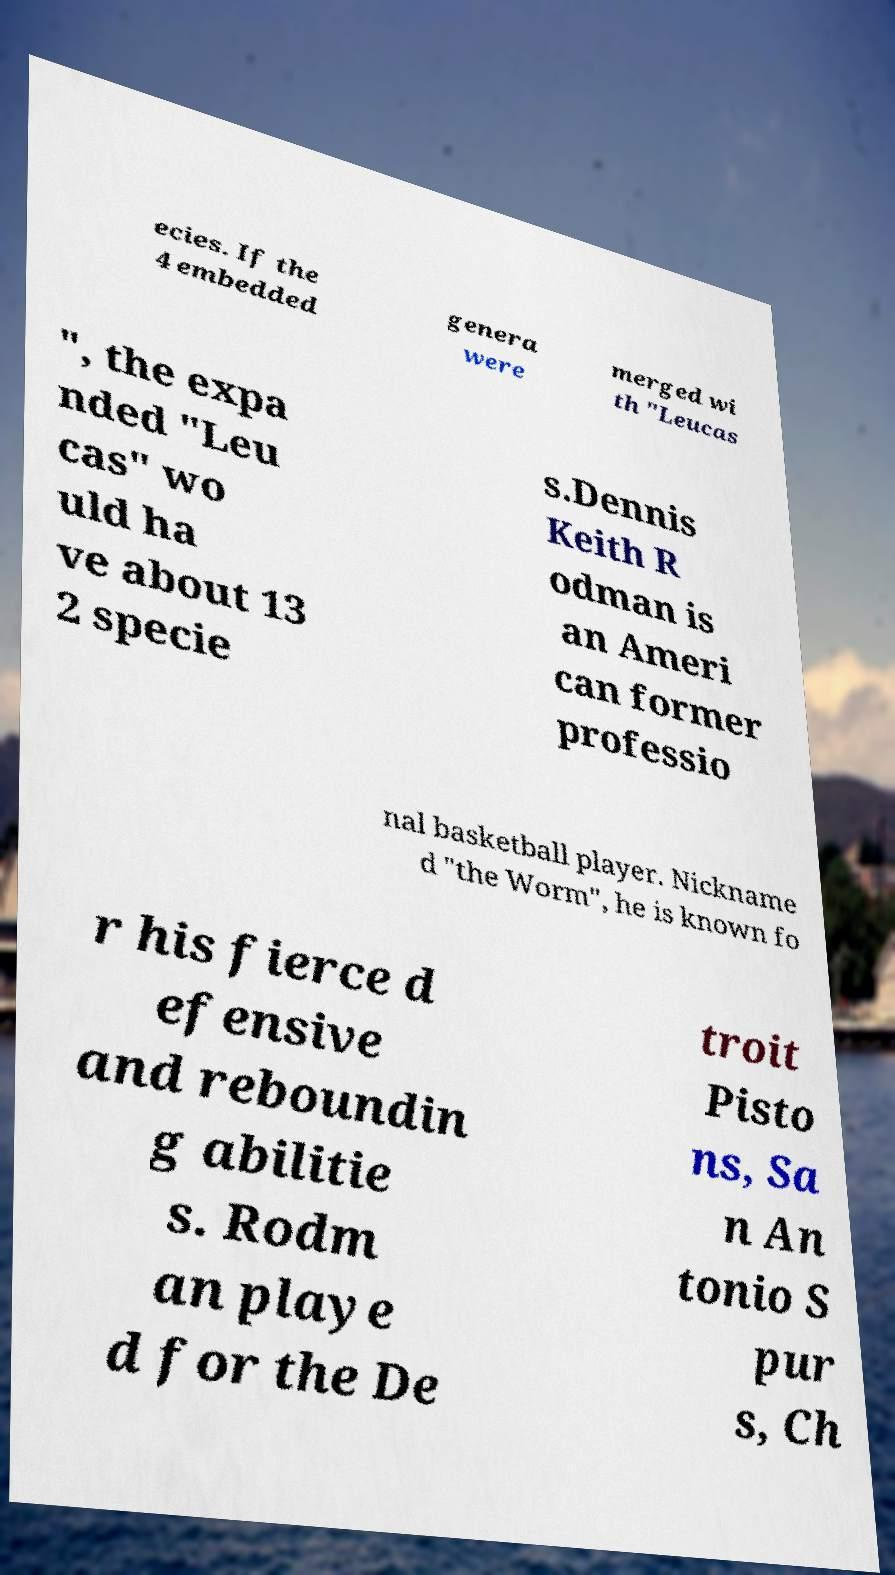What messages or text are displayed in this image? I need them in a readable, typed format. ecies. If the 4 embedded genera were merged wi th "Leucas ", the expa nded "Leu cas" wo uld ha ve about 13 2 specie s.Dennis Keith R odman is an Ameri can former professio nal basketball player. Nickname d "the Worm", he is known fo r his fierce d efensive and reboundin g abilitie s. Rodm an playe d for the De troit Pisto ns, Sa n An tonio S pur s, Ch 